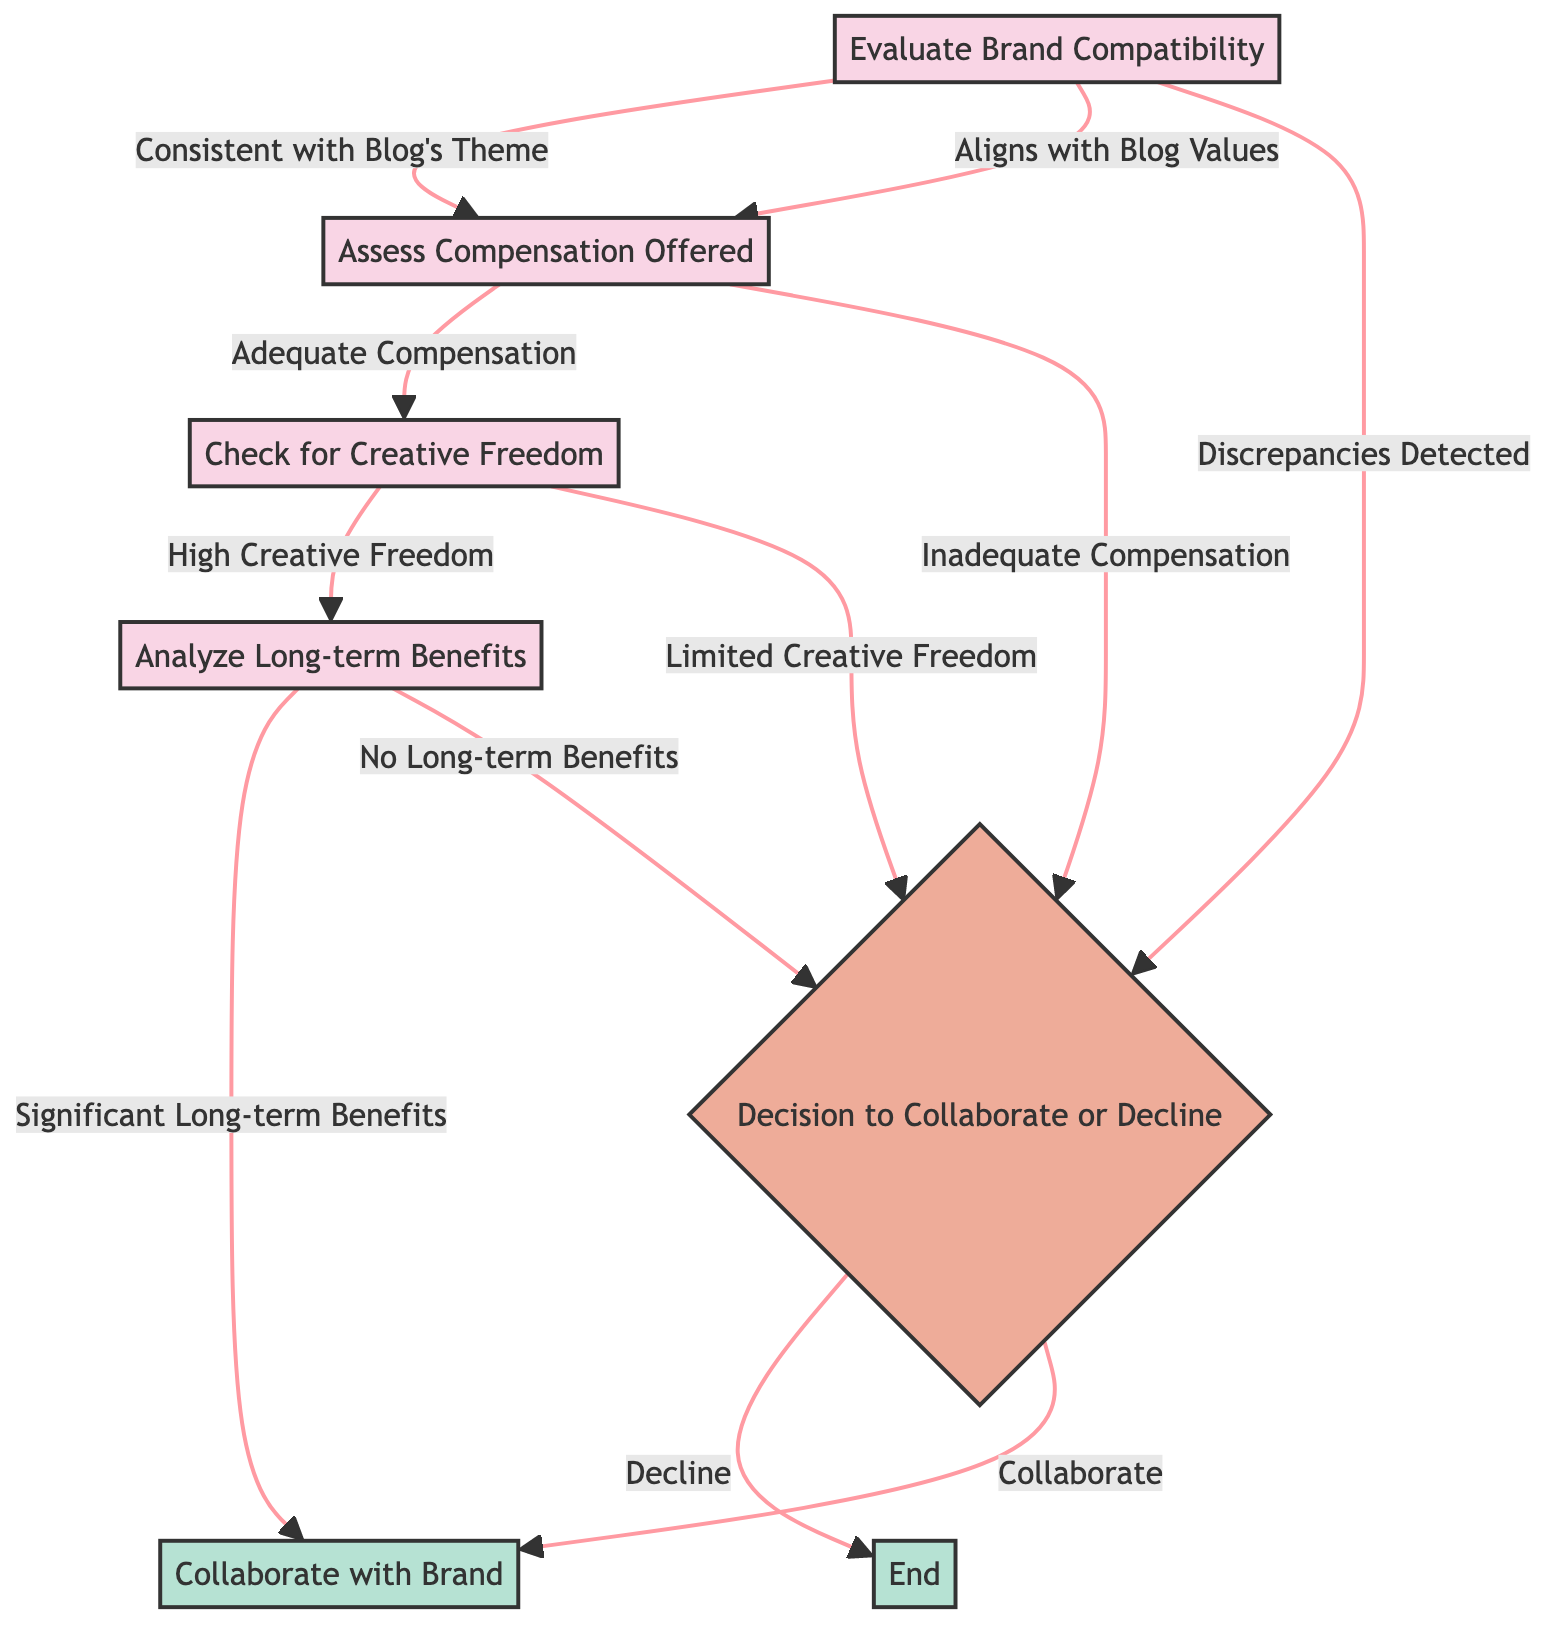What is the first step in the collaboration process? The first step is to evaluate brand compatibility, which is represented in the diagram as node A.
Answer: Evaluate Brand Compatibility How many options are available after evaluating brand compatibility? There are three options available: 'Consistent with Blog's Theme', 'Aligns with Blog Values', and 'Discrepancies Detected'. These are the exit paths from node A.
Answer: Three options What happens if discrepancies are detected during brand compatibility evaluation? If discrepancies are detected, it leads directly to the decision node where the choice to collaborate or decline is made, indicated as node E.
Answer: Decline decision What is assessed after confirming brand compatibility? After confirming brand compatibility, the next assessment is of the compensation offered, represented by node B.
Answer: Assess Compensation Offered How many paths lead to the decision node? There are four paths leading to the decision node E: one from brand compatibility, two from compensation assessment, and one from analyzing long-term benefits.
Answer: Four paths What are the potential outcomes after assessing long-term benefits? The outcomes after assessing long-term benefits can either be 'Significant Long-term Benefits' or 'No Long-term Benefits', leading to the decision node.
Answer: Two outcomes If the compensation is inadequate, what is the next step? If the compensation is inadequate, the next step is to reach the decision node E where the collaboration option will be declined.
Answer: Decision to Decline What leads to the option to collaborate with a brand? The option to collaborate with a brand is reached if the brand compatibility is evaluated positively, compensation is adequate, creative freedom is high, and long-term benefits are significant.
Answer: Collaborate What node represents the final outcomes of the collaboration decision process? The final outcomes of the collaboration decision process are represented by the endpoint nodes F and G, which indicate either collaboration or end.
Answer: Endpoint nodes F and G 